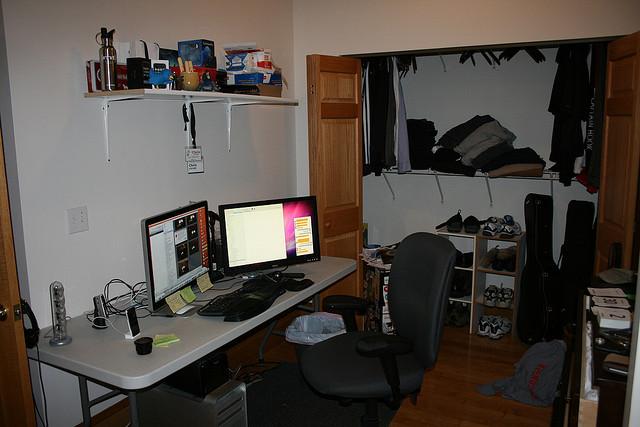What is plugged into the socket?
Be succinct. Computer. What color is the laptop on the right?
Answer briefly. Black. What color is the keyboard?
Concise answer only. Black. What room in a house is this?
Write a very short answer. Office. What is in the center of the desk?
Short answer required. Computer. Is this room ready to be used fully?
Keep it brief. Yes. What type of room is this?
Be succinct. Office. Is there a light on outside?
Quick response, please. No. Is it day or night?
Give a very brief answer. Night. What is the bulkiest piece of electronic equipment on the desk?
Short answer required. Monitor. What room of the house is this?
Concise answer only. Office. Whose room is this?
Concise answer only. Office. How many chairs are there?
Concise answer only. 1. How many monitors are on the desk?
Quick response, please. 2. What is the make of the laptop computer?
Answer briefly. Dell. What part of the is this?
Concise answer only. Office. What material is the desk made of?
Concise answer only. Plastic. What's the table made of?
Give a very brief answer. Plastic. Are there guitars in the picture?
Be succinct. Yes. Is that a desktop or laptop computer sitting on the table?
Write a very short answer. Desktop. What kind of controller is on the table?
Give a very brief answer. Mouse. What is the trashcan next to?
Give a very brief answer. Chair. Is the mouse wireless?
Short answer required. No. What electronic is on the shelf above the computer?
Concise answer only. None. What room is this?
Concise answer only. Bedroom. What is to the right of the TV on the desk?
Short answer required. Monitor. Which room is this?
Quick response, please. Office. What is the room?
Give a very brief answer. Bedroom. 